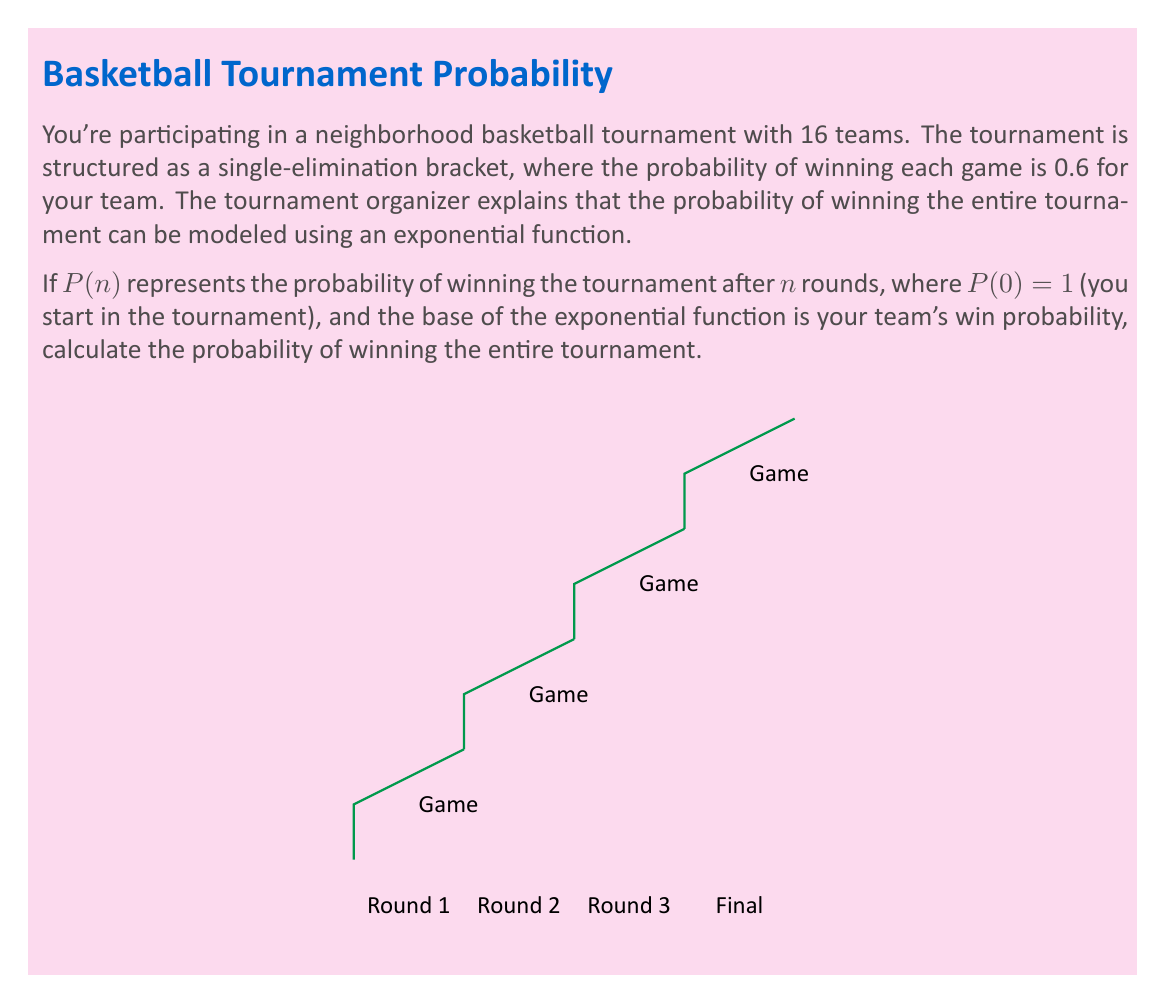Could you help me with this problem? Let's approach this step-by-step:

1) In a single-elimination tournament with 16 teams, you need to win 4 rounds to be the champion.

2) The probability of winning each game is 0.6.

3) The probability function $P(n)$ is an exponential function with base 0.6:

   $P(n) = (0.6)^n$

4) To win the tournament, you need to win all 4 rounds. So we need to calculate $P(4)$:

   $P(4) = (0.6)^4$

5) Let's calculate this:
   
   $P(4) = (0.6)^4 = 0.6 \times 0.6 \times 0.6 \times 0.6 = 0.1296$

6) We can also express this as a fraction:

   $P(4) = \frac{1296}{10000} = \frac{81}{625}$

Therefore, the probability of winning the entire tournament is 0.1296 or $\frac{81}{625}$.
Answer: $\frac{81}{625}$ or 0.1296 